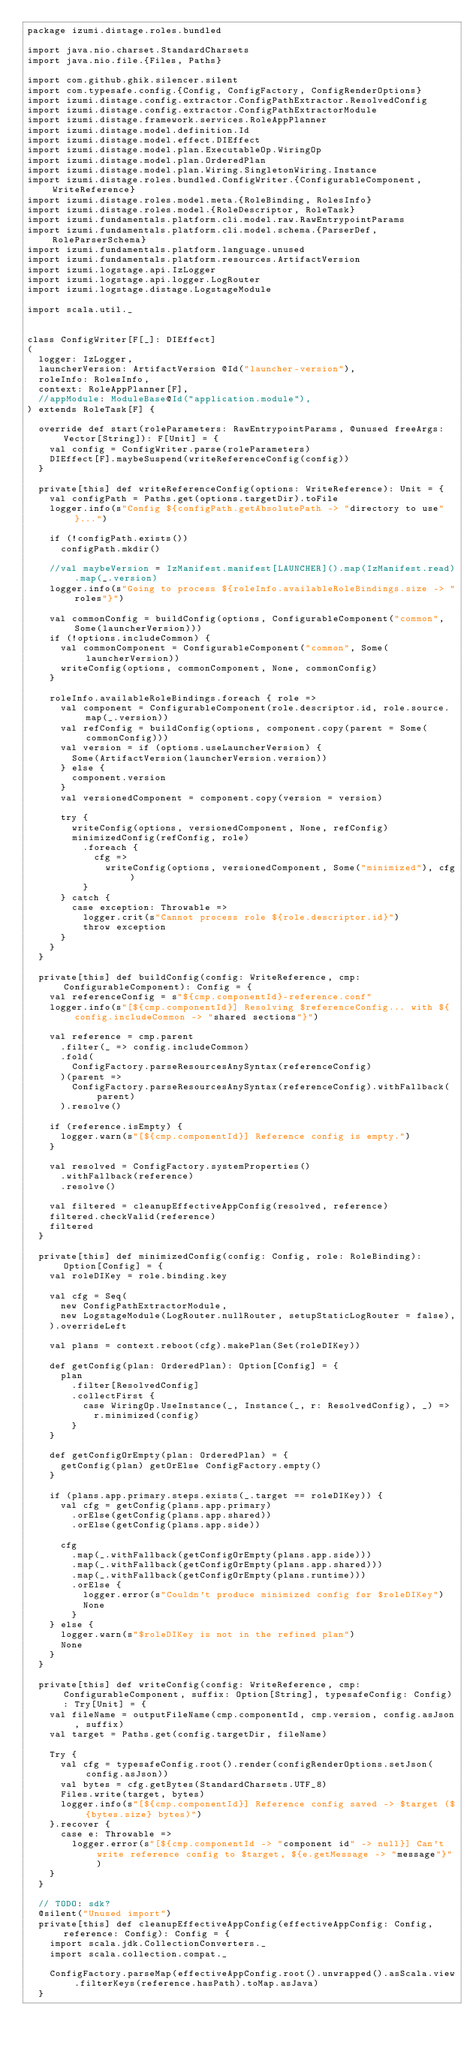Convert code to text. <code><loc_0><loc_0><loc_500><loc_500><_Scala_>package izumi.distage.roles.bundled

import java.nio.charset.StandardCharsets
import java.nio.file.{Files, Paths}

import com.github.ghik.silencer.silent
import com.typesafe.config.{Config, ConfigFactory, ConfigRenderOptions}
import izumi.distage.config.extractor.ConfigPathExtractor.ResolvedConfig
import izumi.distage.config.extractor.ConfigPathExtractorModule
import izumi.distage.framework.services.RoleAppPlanner
import izumi.distage.model.definition.Id
import izumi.distage.model.effect.DIEffect
import izumi.distage.model.plan.ExecutableOp.WiringOp
import izumi.distage.model.plan.OrderedPlan
import izumi.distage.model.plan.Wiring.SingletonWiring.Instance
import izumi.distage.roles.bundled.ConfigWriter.{ConfigurableComponent, WriteReference}
import izumi.distage.roles.model.meta.{RoleBinding, RolesInfo}
import izumi.distage.roles.model.{RoleDescriptor, RoleTask}
import izumi.fundamentals.platform.cli.model.raw.RawEntrypointParams
import izumi.fundamentals.platform.cli.model.schema.{ParserDef, RoleParserSchema}
import izumi.fundamentals.platform.language.unused
import izumi.fundamentals.platform.resources.ArtifactVersion
import izumi.logstage.api.IzLogger
import izumi.logstage.api.logger.LogRouter
import izumi.logstage.distage.LogstageModule

import scala.util._


class ConfigWriter[F[_]: DIEffect]
(
  logger: IzLogger,
  launcherVersion: ArtifactVersion @Id("launcher-version"),
  roleInfo: RolesInfo,
  context: RoleAppPlanner[F],
  //appModule: ModuleBase@Id("application.module"),
) extends RoleTask[F] {

  override def start(roleParameters: RawEntrypointParams, @unused freeArgs: Vector[String]): F[Unit] = {
    val config = ConfigWriter.parse(roleParameters)
    DIEffect[F].maybeSuspend(writeReferenceConfig(config))
  }

  private[this] def writeReferenceConfig(options: WriteReference): Unit = {
    val configPath = Paths.get(options.targetDir).toFile
    logger.info(s"Config ${configPath.getAbsolutePath -> "directory to use"}...")

    if (!configPath.exists())
      configPath.mkdir()

    //val maybeVersion = IzManifest.manifest[LAUNCHER]().map(IzManifest.read).map(_.version)
    logger.info(s"Going to process ${roleInfo.availableRoleBindings.size -> "roles"}")

    val commonConfig = buildConfig(options, ConfigurableComponent("common", Some(launcherVersion)))
    if (!options.includeCommon) {
      val commonComponent = ConfigurableComponent("common", Some(launcherVersion))
      writeConfig(options, commonComponent, None, commonConfig)
    }

    roleInfo.availableRoleBindings.foreach { role =>
      val component = ConfigurableComponent(role.descriptor.id, role.source.map(_.version))
      val refConfig = buildConfig(options, component.copy(parent = Some(commonConfig)))
      val version = if (options.useLauncherVersion) {
        Some(ArtifactVersion(launcherVersion.version))
      } else {
        component.version
      }
      val versionedComponent = component.copy(version = version)

      try {
        writeConfig(options, versionedComponent, None, refConfig)
        minimizedConfig(refConfig, role)
          .foreach {
            cfg =>
              writeConfig(options, versionedComponent, Some("minimized"), cfg)
          }
      } catch {
        case exception: Throwable =>
          logger.crit(s"Cannot process role ${role.descriptor.id}")
          throw exception
      }
    }
  }

  private[this] def buildConfig(config: WriteReference, cmp: ConfigurableComponent): Config = {
    val referenceConfig = s"${cmp.componentId}-reference.conf"
    logger.info(s"[${cmp.componentId}] Resolving $referenceConfig... with ${config.includeCommon -> "shared sections"}")

    val reference = cmp.parent
      .filter(_ => config.includeCommon)
      .fold(
        ConfigFactory.parseResourcesAnySyntax(referenceConfig)
      )(parent =>
        ConfigFactory.parseResourcesAnySyntax(referenceConfig).withFallback(parent)
      ).resolve()

    if (reference.isEmpty) {
      logger.warn(s"[${cmp.componentId}] Reference config is empty.")
    }

    val resolved = ConfigFactory.systemProperties()
      .withFallback(reference)
      .resolve()

    val filtered = cleanupEffectiveAppConfig(resolved, reference)
    filtered.checkValid(reference)
    filtered
  }

  private[this] def minimizedConfig(config: Config, role: RoleBinding): Option[Config] = {
    val roleDIKey = role.binding.key

    val cfg = Seq(
      new ConfigPathExtractorModule,
      new LogstageModule(LogRouter.nullRouter, setupStaticLogRouter = false),
    ).overrideLeft

    val plans = context.reboot(cfg).makePlan(Set(roleDIKey))

    def getConfig(plan: OrderedPlan): Option[Config] = {
      plan
        .filter[ResolvedConfig]
        .collectFirst {
          case WiringOp.UseInstance(_, Instance(_, r: ResolvedConfig), _) =>
            r.minimized(config)
        }
    }

    def getConfigOrEmpty(plan: OrderedPlan) = {
      getConfig(plan) getOrElse ConfigFactory.empty()
    }

    if (plans.app.primary.steps.exists(_.target == roleDIKey)) {
      val cfg = getConfig(plans.app.primary)
        .orElse(getConfig(plans.app.shared))
        .orElse(getConfig(plans.app.side))

      cfg
        .map(_.withFallback(getConfigOrEmpty(plans.app.side)))
        .map(_.withFallback(getConfigOrEmpty(plans.app.shared)))
        .map(_.withFallback(getConfigOrEmpty(plans.runtime)))
        .orElse {
          logger.error(s"Couldn't produce minimized config for $roleDIKey")
          None
        }
    } else {
      logger.warn(s"$roleDIKey is not in the refined plan")
      None
    }
  }

  private[this] def writeConfig(config: WriteReference, cmp: ConfigurableComponent, suffix: Option[String], typesafeConfig: Config): Try[Unit] = {
    val fileName = outputFileName(cmp.componentId, cmp.version, config.asJson, suffix)
    val target = Paths.get(config.targetDir, fileName)

    Try {
      val cfg = typesafeConfig.root().render(configRenderOptions.setJson(config.asJson))
      val bytes = cfg.getBytes(StandardCharsets.UTF_8)
      Files.write(target, bytes)
      logger.info(s"[${cmp.componentId}] Reference config saved -> $target (${bytes.size} bytes)")
    }.recover {
      case e: Throwable =>
        logger.error(s"[${cmp.componentId -> "component id" -> null}] Can't write reference config to $target, ${e.getMessage -> "message"}")
    }
  }

  // TODO: sdk?
  @silent("Unused import")
  private[this] def cleanupEffectiveAppConfig(effectiveAppConfig: Config, reference: Config): Config = {
    import scala.jdk.CollectionConverters._
    import scala.collection.compat._

    ConfigFactory.parseMap(effectiveAppConfig.root().unwrapped().asScala.view.filterKeys(reference.hasPath).toMap.asJava)
  }
</code> 